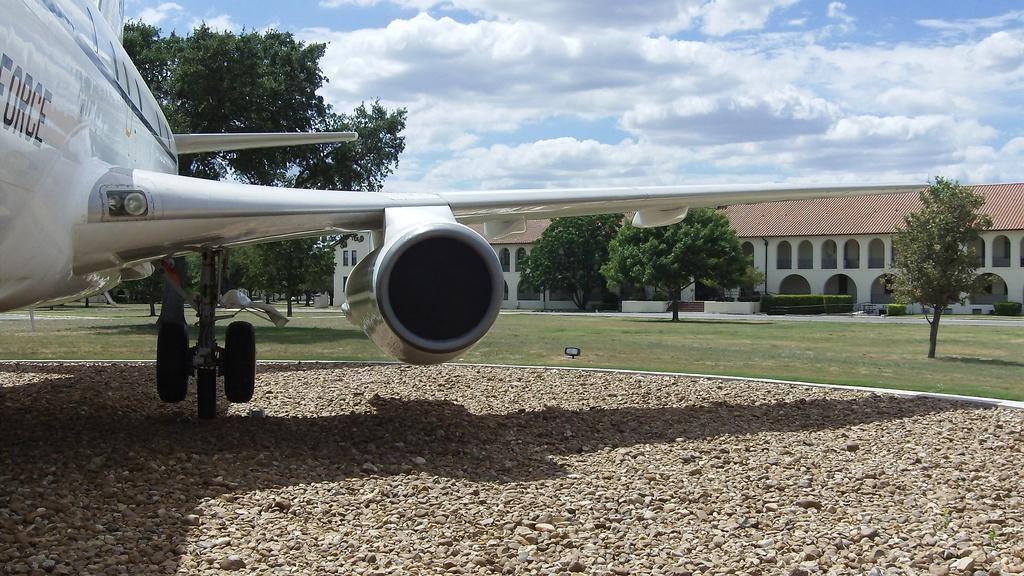<image>
Create a compact narrative representing the image presented. a private plane with the word FORCE is sitting on a gravel area in front of a large house 